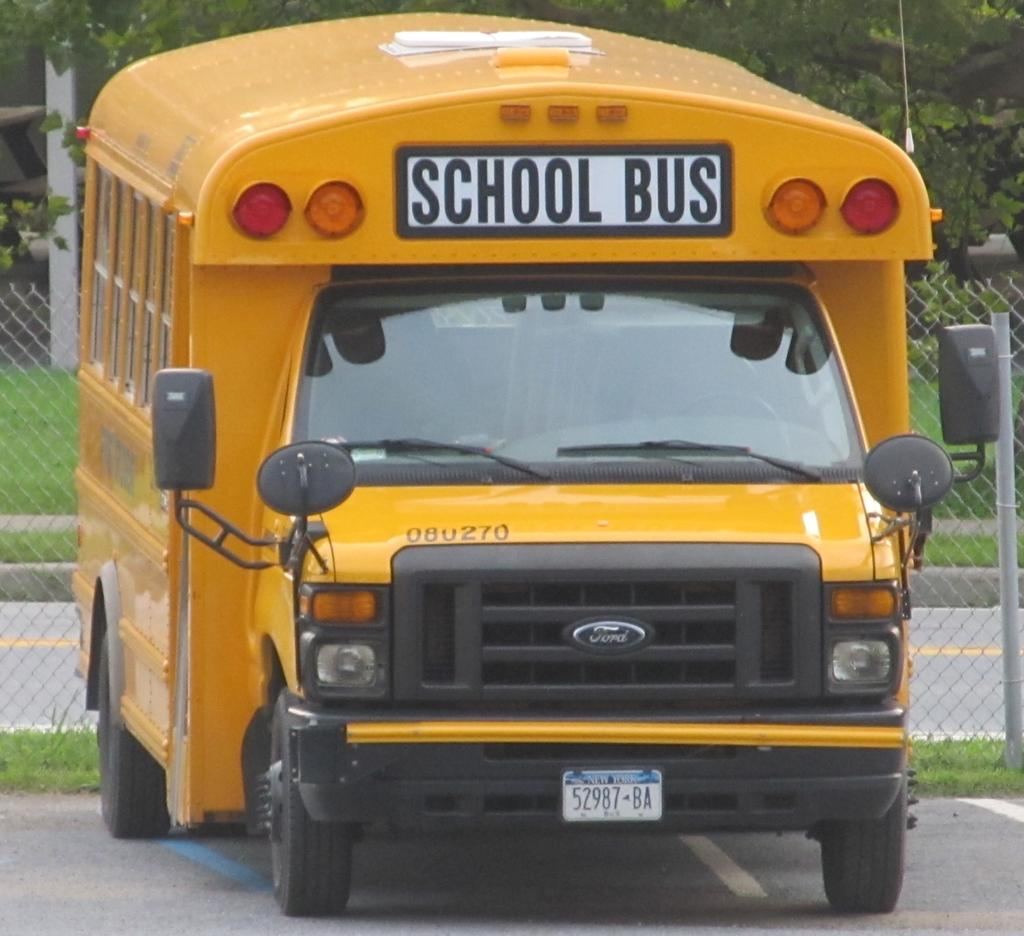<image>
Present a compact description of the photo's key features. A school bus is parked in front of a metal fence. 